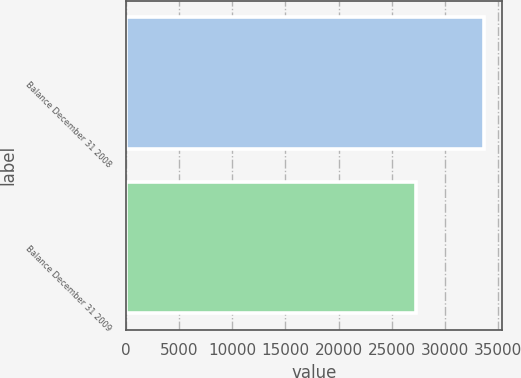Convert chart. <chart><loc_0><loc_0><loc_500><loc_500><bar_chart><fcel>Balance December 31 2008<fcel>Balance December 31 2009<nl><fcel>33654<fcel>27258<nl></chart> 